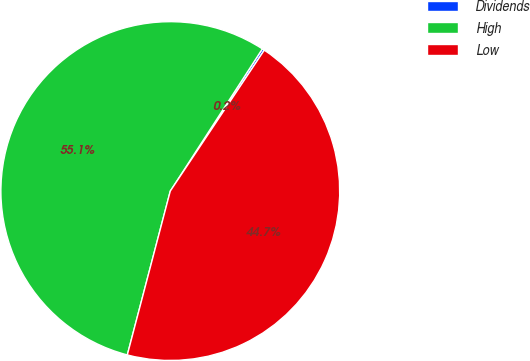Convert chart. <chart><loc_0><loc_0><loc_500><loc_500><pie_chart><fcel>Dividends<fcel>High<fcel>Low<nl><fcel>0.22%<fcel>55.06%<fcel>44.72%<nl></chart> 